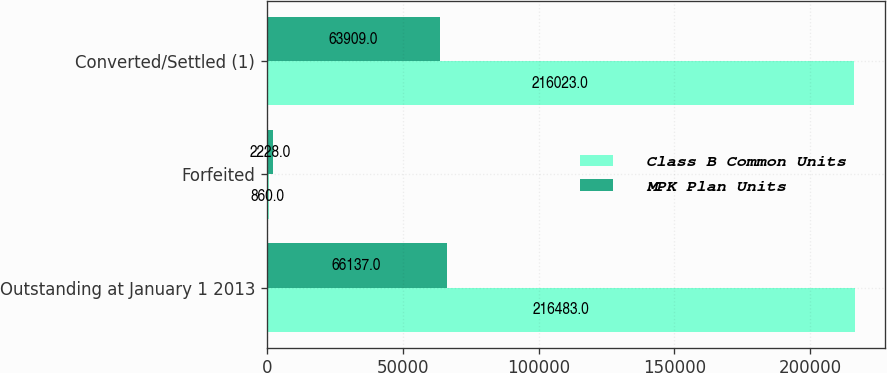<chart> <loc_0><loc_0><loc_500><loc_500><stacked_bar_chart><ecel><fcel>Outstanding at January 1 2013<fcel>Forfeited<fcel>Converted/Settled (1)<nl><fcel>Class B Common Units<fcel>216483<fcel>860<fcel>216023<nl><fcel>MPK Plan Units<fcel>66137<fcel>2228<fcel>63909<nl></chart> 